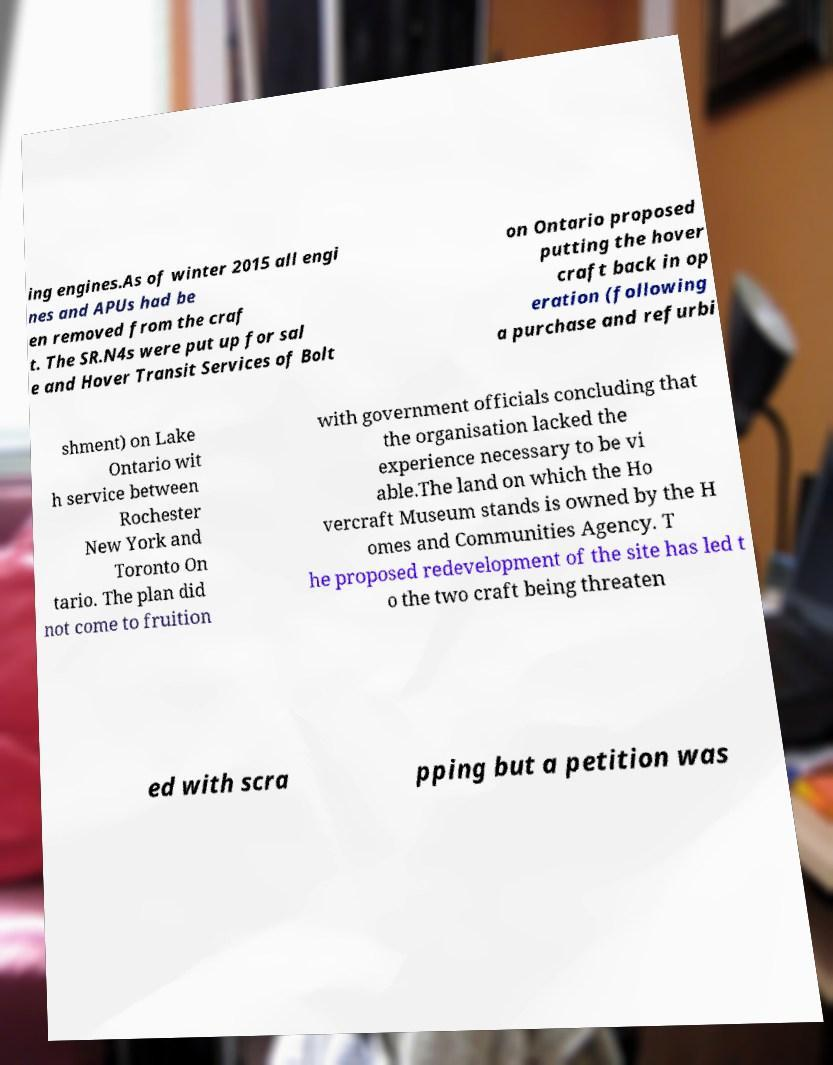Can you read and provide the text displayed in the image?This photo seems to have some interesting text. Can you extract and type it out for me? ing engines.As of winter 2015 all engi nes and APUs had be en removed from the craf t. The SR.N4s were put up for sal e and Hover Transit Services of Bolt on Ontario proposed putting the hover craft back in op eration (following a purchase and refurbi shment) on Lake Ontario wit h service between Rochester New York and Toronto On tario. The plan did not come to fruition with government officials concluding that the organisation lacked the experience necessary to be vi able.The land on which the Ho vercraft Museum stands is owned by the H omes and Communities Agency. T he proposed redevelopment of the site has led t o the two craft being threaten ed with scra pping but a petition was 